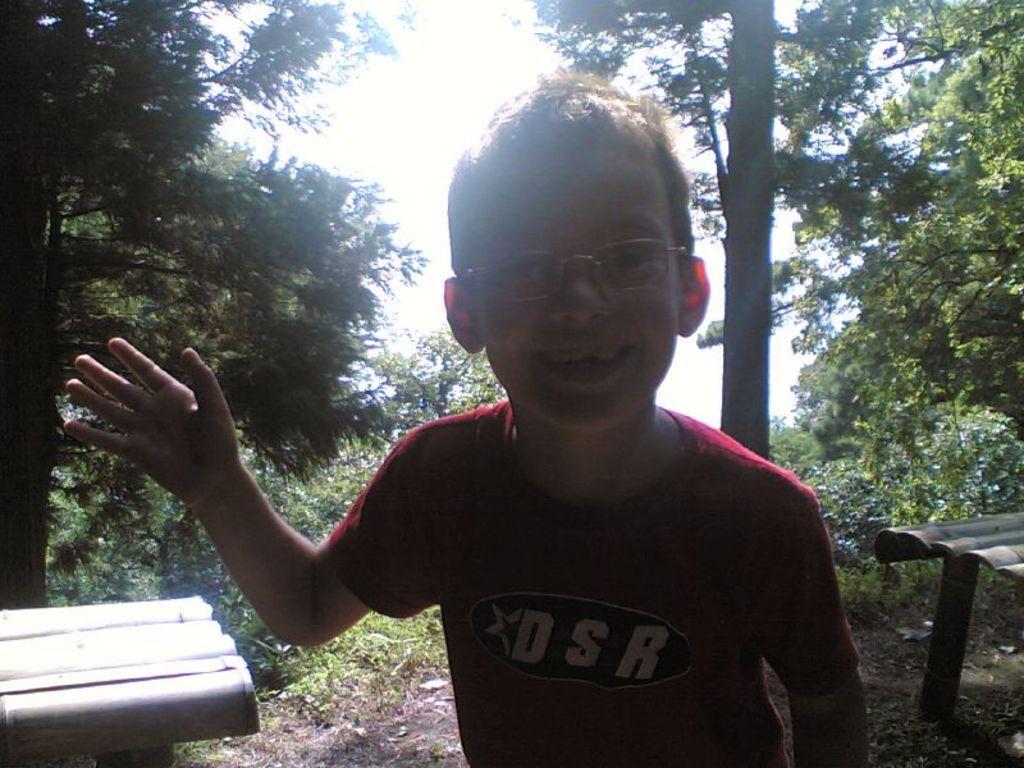Please provide a concise description of this image. In this image I can see the person wearing the maroon color dress and also with specs. To the side I can see the wooden objects. In the back there are many trees and the sky. 